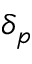Convert formula to latex. <formula><loc_0><loc_0><loc_500><loc_500>\delta _ { p }</formula> 